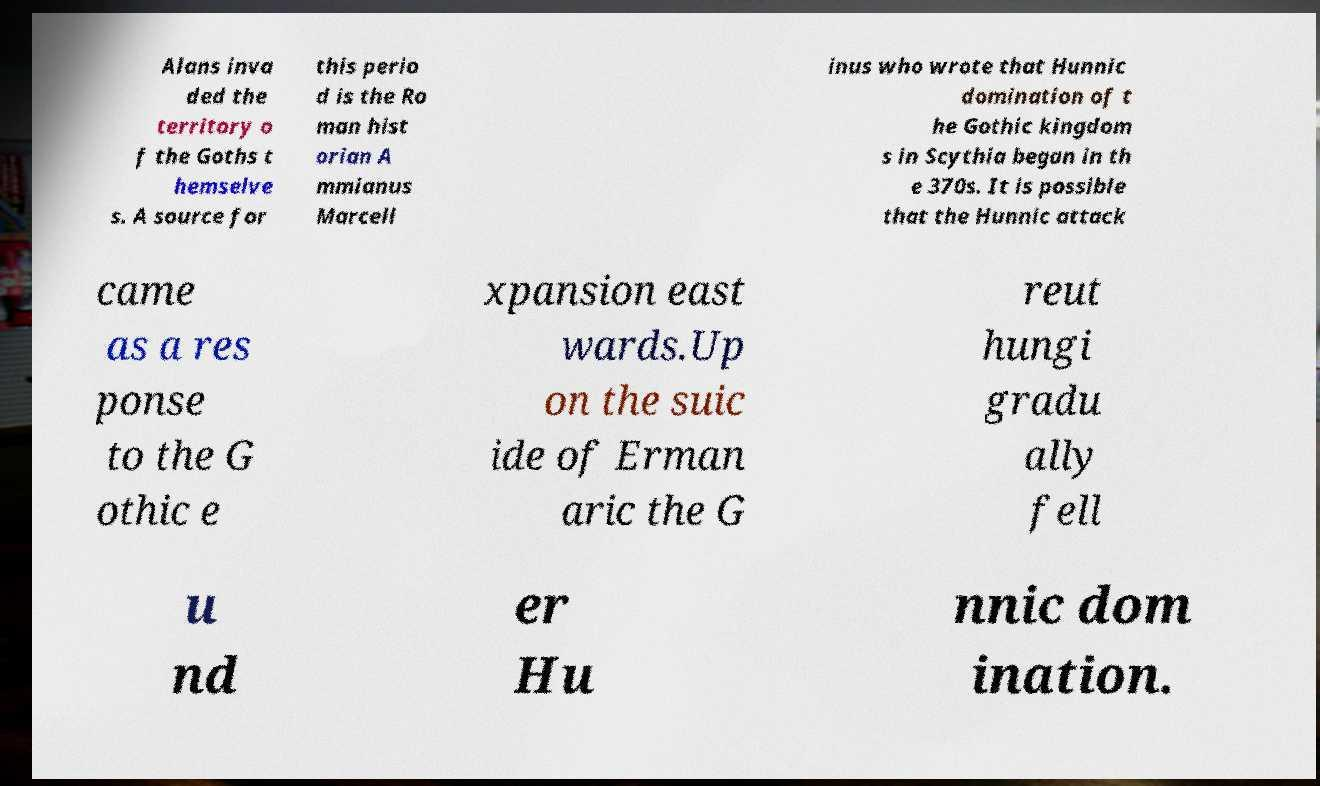I need the written content from this picture converted into text. Can you do that? Alans inva ded the territory o f the Goths t hemselve s. A source for this perio d is the Ro man hist orian A mmianus Marcell inus who wrote that Hunnic domination of t he Gothic kingdom s in Scythia began in th e 370s. It is possible that the Hunnic attack came as a res ponse to the G othic e xpansion east wards.Up on the suic ide of Erman aric the G reut hungi gradu ally fell u nd er Hu nnic dom ination. 